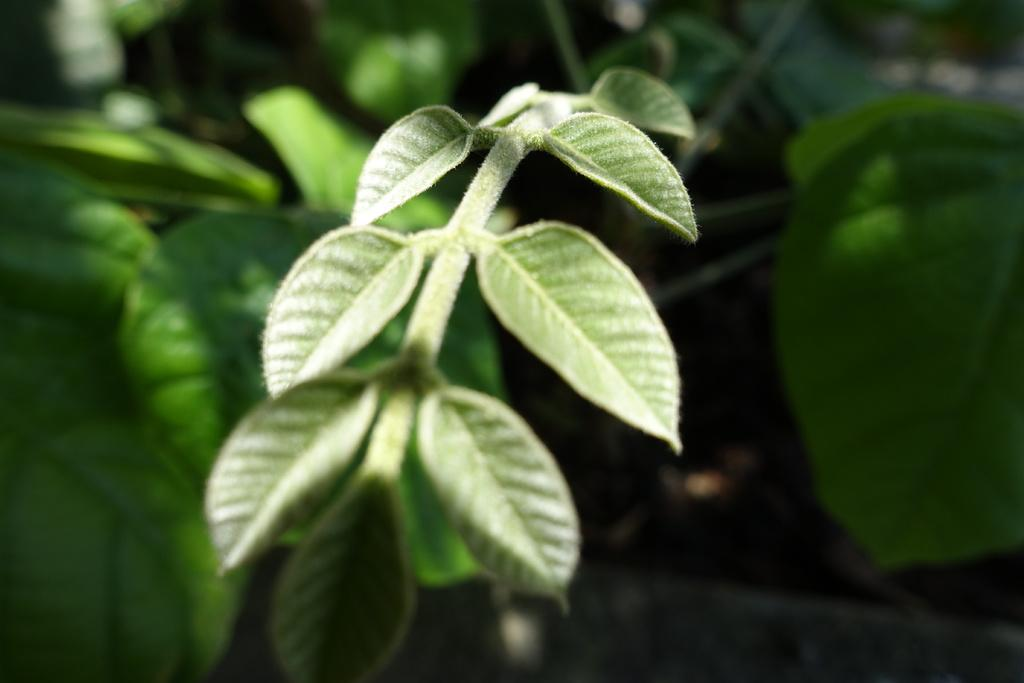What celestial bodies are depicted in the image? There are planets in the image. What type of structure can be seen in the image? There is a fence in the image. Can you describe the setting of the image? The image may have been taken in a garden. What type of creature can be seen interacting with the planets in the image? There is no creature present in the image; it only features planets and a fence. What message is written on the note that is visible in the image? There is no note present in the image. 